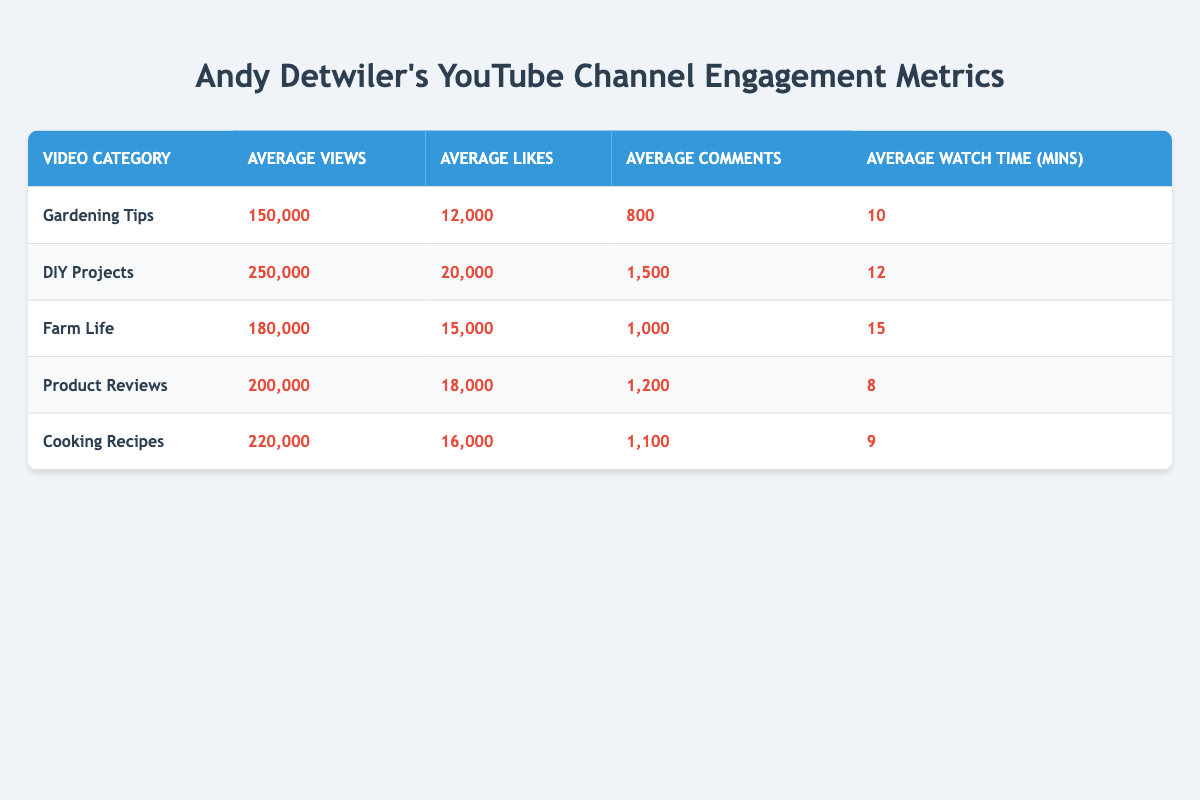What category has the highest average views? The data shows the "DIY Projects" category has the highest average views at 250,000, which is noted in the corresponding row for this category.
Answer: DIY Projects What is the average number of likes for "Cooking Recipes"? The average number of likes for "Cooking Recipes" is 16,000, which can be found in the row for this category in the table.
Answer: 16,000 Which category has the lowest average watch time? The category with the lowest average watch time is "Product Reviews," which has an average of 8 minutes, seen directly in the table.
Answer: Product Reviews What is the difference in average views between "Gardening Tips" and "Farm Life"? The average views for "Gardening Tips" is 150,000 and for "Farm Life" is 180,000. The difference is calculated by subtracting 150,000 from 180,000, which equals 30,000.
Answer: 30,000 Is the average number of comments higher for "DIY Projects" than for "Product Reviews"? "DIY Projects" has an average of 1,500 comments while "Product Reviews" has 1,200 comments, showing that DIY Projects has more comments. Thus, the answer is yes.
Answer: Yes What is the total average number of likes across all categories? To find the total average number of likes, we sum the average likes for all categories: 12,000 + 20,000 + 15,000 + 18,000 + 16,000 = 81,000. Then, we divide by the number of categories, which is 5, giving us 81,000 / 5 = 16,200.
Answer: 16,200 Which category ranks second in average likes? The average likes for each category shows "Product Reviews" has 18,000, "Farm Life" has 15,000, and "Cooking Recipes" has 16,000. Arranging by likes, the second-highest is "Product Reviews" with 18,000 likes.
Answer: Product Reviews How does the average watch time for "DIY Projects" compare to that of "Cooking Recipes"? "DIY Projects" has an average watch time of 12 minutes, while "Cooking Recipes" has 9 minutes. Therefore, DIY Projects has 3 more minutes on average.
Answer: 3 more minutes Which video category has the highest average likes and what is that value? The highest average likes are 20,000, found in the "DIY Projects" category, as is evident when comparing the averages in the table.
Answer: 20,000 